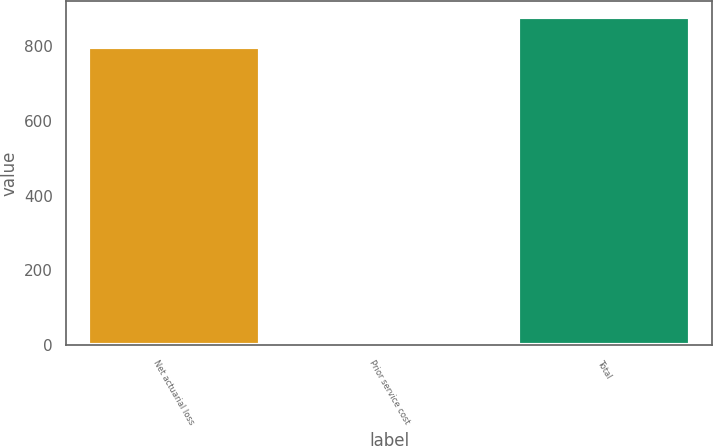Convert chart to OTSL. <chart><loc_0><loc_0><loc_500><loc_500><bar_chart><fcel>Net actuarial loss<fcel>Prior service cost<fcel>Total<nl><fcel>798.2<fcel>11.7<fcel>878.02<nl></chart> 